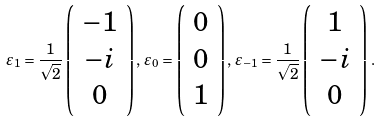Convert formula to latex. <formula><loc_0><loc_0><loc_500><loc_500>\varepsilon _ { 1 } = \frac { 1 } { \sqrt { 2 } } \left ( \begin{array} { c } { - 1 } \\ { - i } \\ { 0 } \end{array} \right ) , \, \varepsilon _ { 0 } = \left ( \begin{array} { c } { 0 } \\ { 0 } \\ { 1 } \end{array} \right ) , \, \varepsilon _ { - 1 } = \frac { 1 } { \sqrt { 2 } } \left ( \begin{array} { c } { 1 } \\ { - i } \\ { 0 } \end{array} \right ) \, .</formula> 